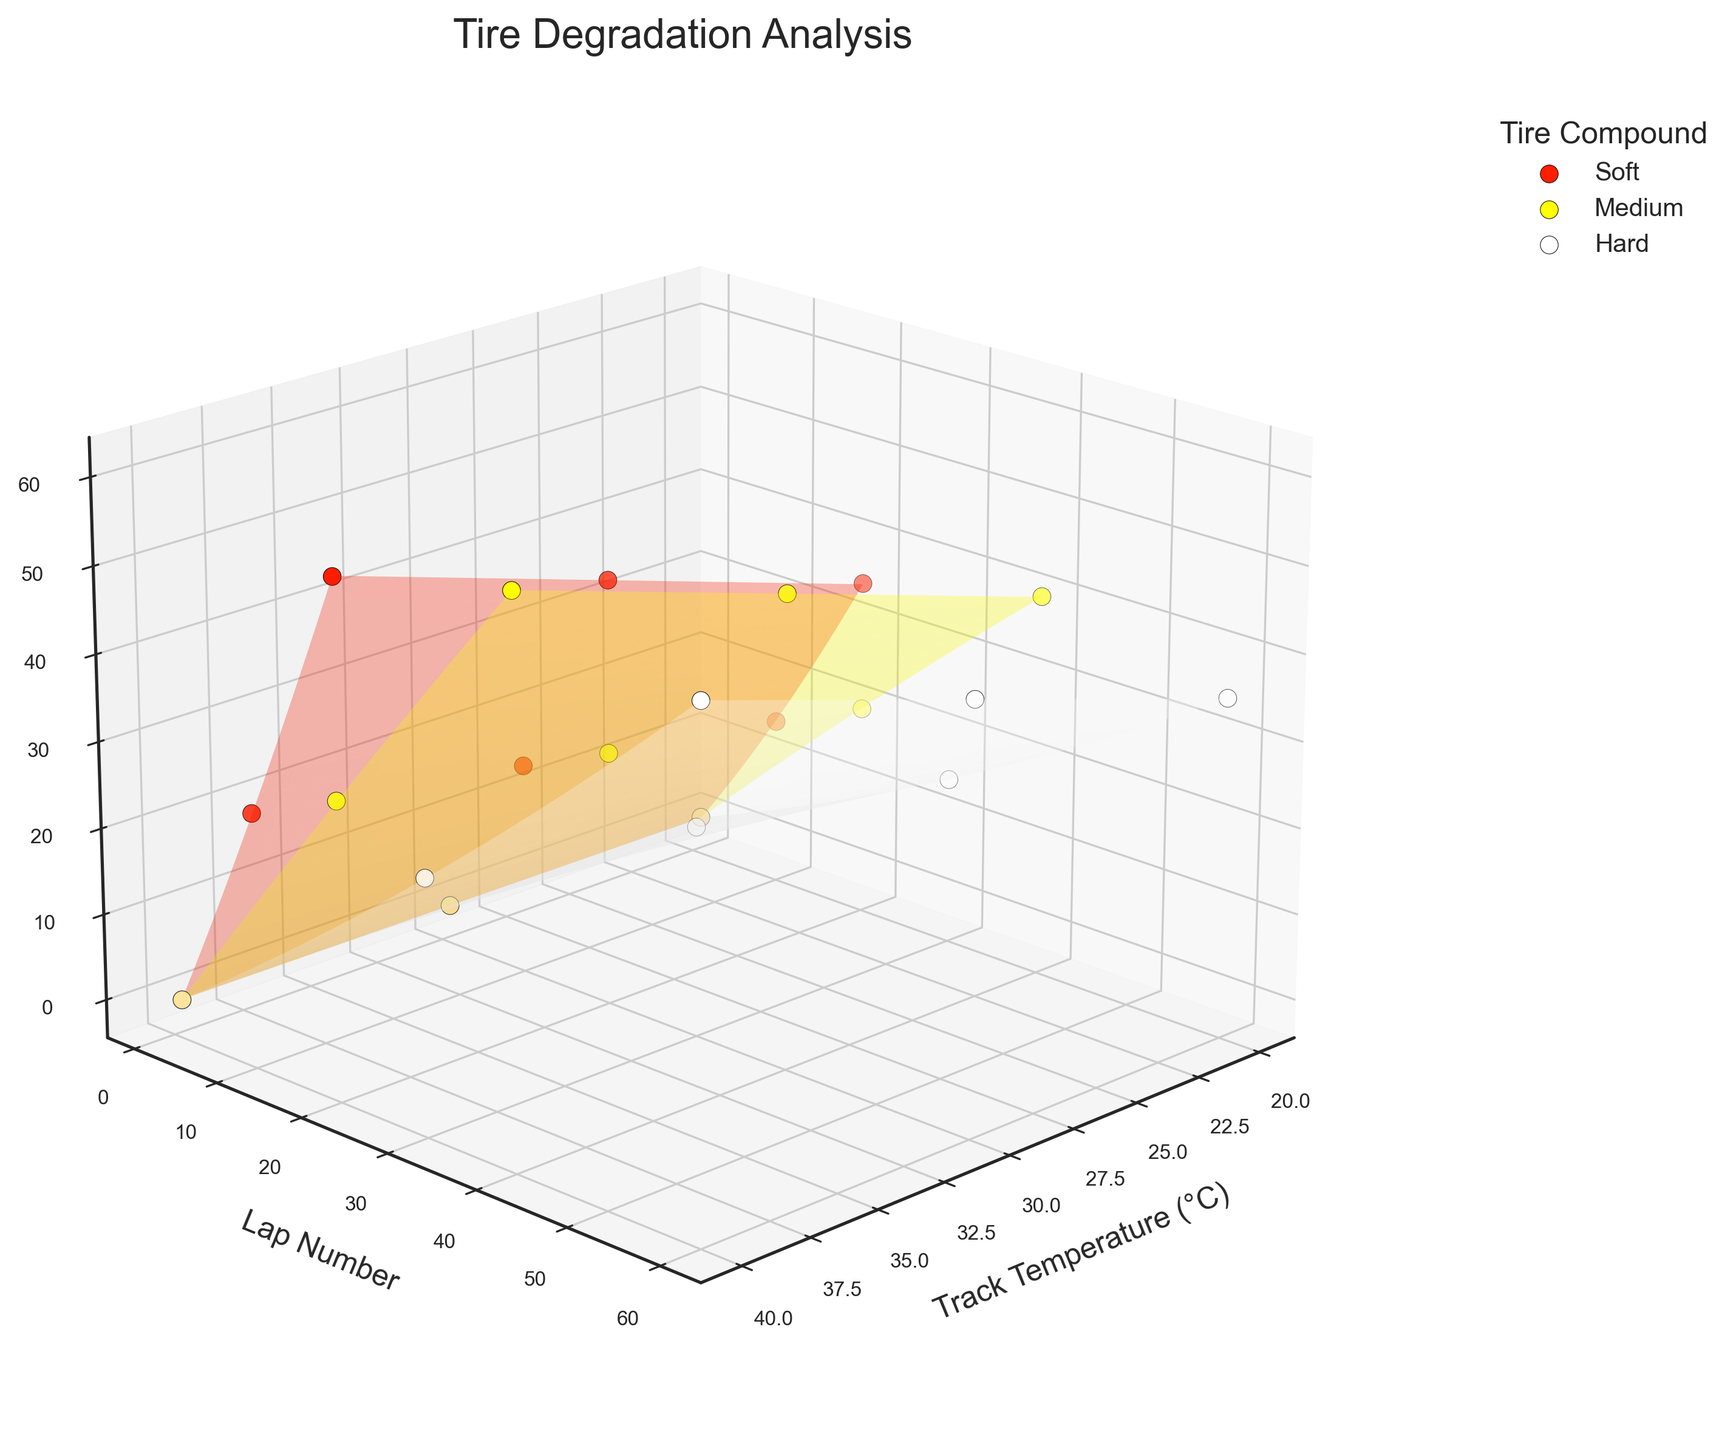How many tire compounds are analyzed in the figure? The figure shows three different colors representing Soft, Medium, and Hard tire compounds.
Answer: Three What is the relationship between track temperature and tire wear for Soft compounds? As track temperature increases, the tire wear percentage for Soft compounds increases more rapidly. This can be observed from the higher and steeper surface in the plot for Soft tires.
Answer: Increases rapidly At which lap number does the Hard compound show approximately 35% wear at 30°C track temperature? By locating the Hard tire data points and surfaces, at track temperature of 30°C, the Hard compound hits around 35% wear at about lap 60.
Answer: Lap 60 Which tire compound shows the least wear over 60 laps at the highest track temperature? The Hard compound surface at 40°C has a lower wear percentage than the Soft and Medium compounds over 60 laps.
Answer: Hard Compare the tire wear rate of Medium and Hard compounds at 20°C track temperature over the first 40 laps. At 20°C, the Medium compound reaches 40% wear at 40 laps, whereas the Hard compound reaches only about 15% wear at 30 laps. Thus, Medium compounds wear much faster.
Answer: Medium How does the tire wear of the Soft compound change from lap 1 to lap 20 at 40°C track temperature? Observing the plot, the Soft compound at 40°C starts at 0% wear and reaches around 55% wear by lap 20.
Answer: From 0% to 55% What can be inferred about the effect of track temperature on tire wear for Medium compounds over 20 laps? Higher track temperatures lead to higher tire wear percentages for Medium compounds. At 20°C, wear is 20%, at 30°C it's 25%, and at 40°C it's about 30%.
Answer: Higher temperature increases wear Which tire compound has the most significant increase in wear from 20°C to 40°C over 20 laps? The Soft compound shows the most significant increase, from 35% wear at 20°C to 55% wear at 40°C over 20 laps.
Answer: Soft What is the general trend of tire wear percentages across all compounds as the lap number increases? Across all compounds, tire wear percentage generally increases as the lap number increases, which can be seen from the rising surfaces for each tire compound in the plot.
Answer: Increases 